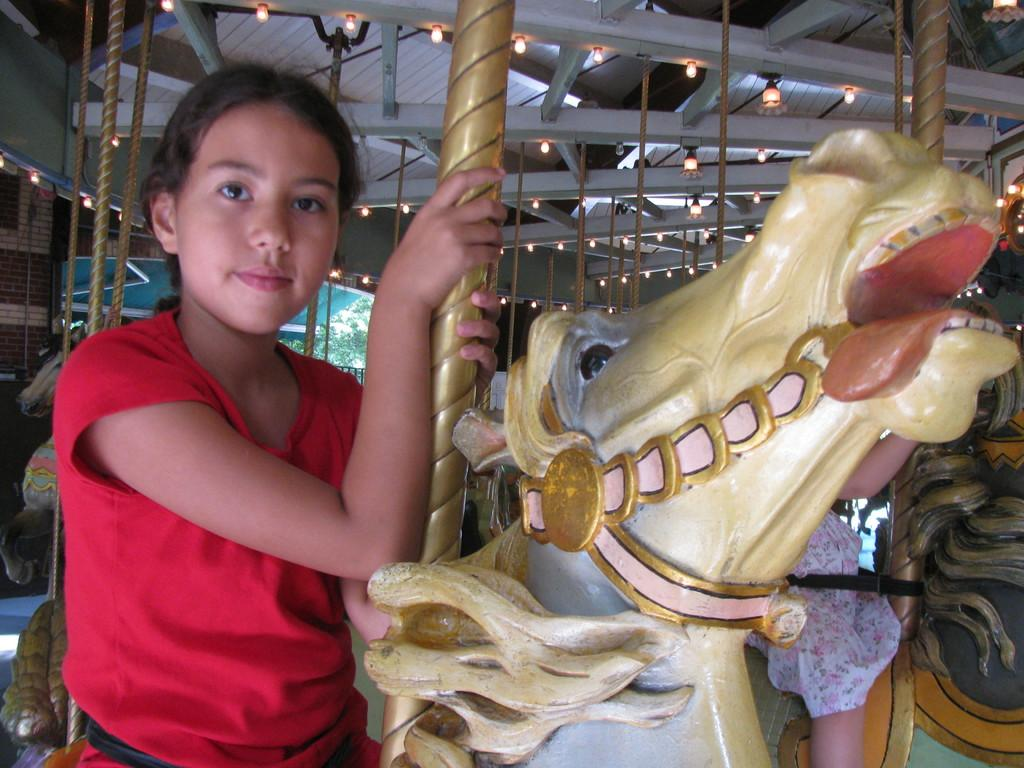Who is the main subject in the image? There is a girl in the image. What is the girl doing in the image? The girl is sitting on a toy horse. What can be seen in the background of the image? There are lights visible in the background of the image. What type of brass instrument is the girl playing in the image? There is no brass instrument present in the image; the girl is sitting on a toy horse. 